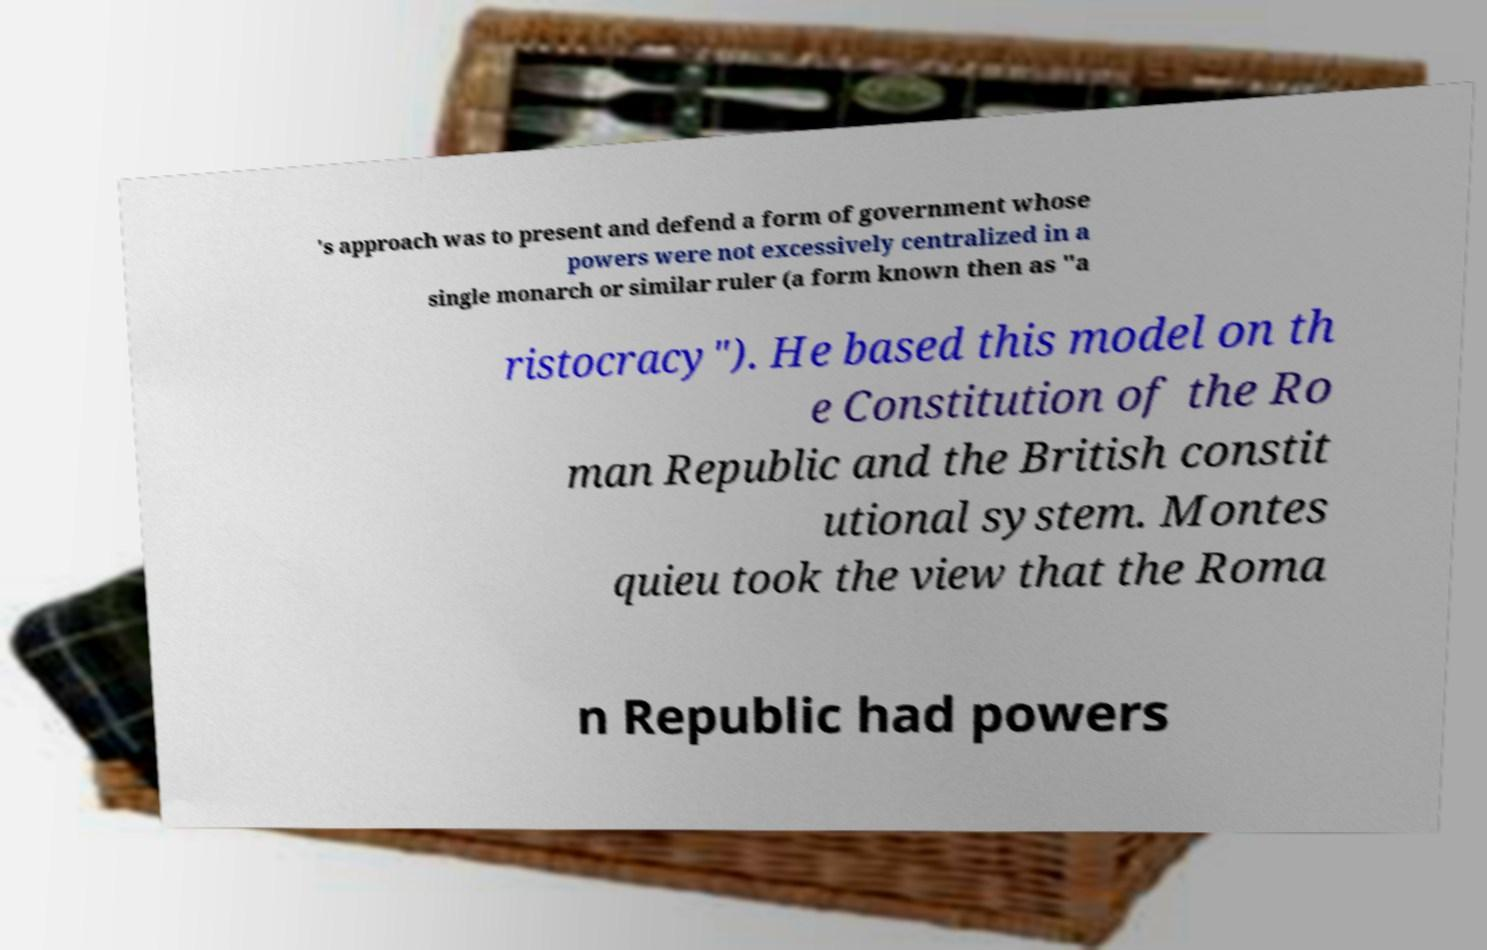I need the written content from this picture converted into text. Can you do that? 's approach was to present and defend a form of government whose powers were not excessively centralized in a single monarch or similar ruler (a form known then as "a ristocracy"). He based this model on th e Constitution of the Ro man Republic and the British constit utional system. Montes quieu took the view that the Roma n Republic had powers 